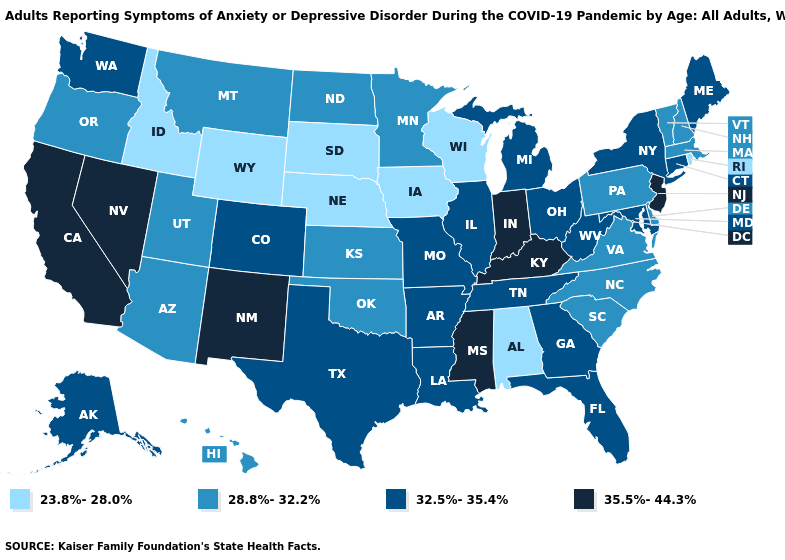Does Indiana have the highest value in the USA?
Be succinct. Yes. What is the lowest value in the Northeast?
Be succinct. 23.8%-28.0%. What is the lowest value in states that border Mississippi?
Concise answer only. 23.8%-28.0%. What is the value of New Mexico?
Keep it brief. 35.5%-44.3%. Name the states that have a value in the range 28.8%-32.2%?
Be succinct. Arizona, Delaware, Hawaii, Kansas, Massachusetts, Minnesota, Montana, New Hampshire, North Carolina, North Dakota, Oklahoma, Oregon, Pennsylvania, South Carolina, Utah, Vermont, Virginia. Does New Jersey have the highest value in the USA?
Answer briefly. Yes. Among the states that border Virginia , does Kentucky have the lowest value?
Keep it brief. No. Which states have the highest value in the USA?
Keep it brief. California, Indiana, Kentucky, Mississippi, Nevada, New Jersey, New Mexico. Does Iowa have the lowest value in the USA?
Quick response, please. Yes. Name the states that have a value in the range 28.8%-32.2%?
Be succinct. Arizona, Delaware, Hawaii, Kansas, Massachusetts, Minnesota, Montana, New Hampshire, North Carolina, North Dakota, Oklahoma, Oregon, Pennsylvania, South Carolina, Utah, Vermont, Virginia. Name the states that have a value in the range 32.5%-35.4%?
Quick response, please. Alaska, Arkansas, Colorado, Connecticut, Florida, Georgia, Illinois, Louisiana, Maine, Maryland, Michigan, Missouri, New York, Ohio, Tennessee, Texas, Washington, West Virginia. Among the states that border Maryland , does West Virginia have the lowest value?
Short answer required. No. Does New Mexico have a lower value than Massachusetts?
Quick response, please. No. What is the highest value in the USA?
Keep it brief. 35.5%-44.3%. What is the value of Wisconsin?
Concise answer only. 23.8%-28.0%. 